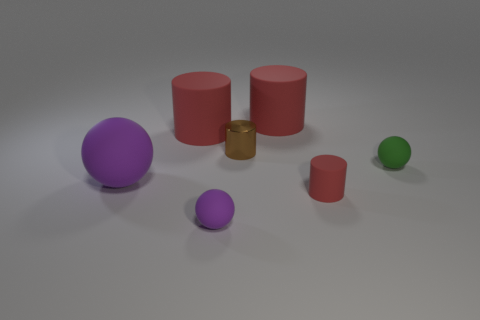Is there any other thing that is the same color as the metal object?
Make the answer very short. No. There is another tiny thing that is the same shape as the small purple rubber thing; what is its color?
Offer a very short reply. Green. Is the number of big rubber cylinders that are left of the small brown cylinder greater than the number of big red shiny balls?
Your response must be concise. Yes. There is a small cylinder that is in front of the small green matte sphere; what is its color?
Your answer should be very brief. Red. Does the metal object have the same size as the green thing?
Ensure brevity in your answer.  Yes. The green rubber object is what size?
Provide a succinct answer. Small. What is the shape of the tiny rubber thing that is the same color as the large ball?
Your answer should be compact. Sphere. Are there more small yellow blocks than tiny shiny cylinders?
Give a very brief answer. No. What is the color of the small sphere that is in front of the large thing that is left of the cylinder left of the small purple matte ball?
Keep it short and to the point. Purple. Does the red rubber object that is in front of the big purple rubber object have the same shape as the tiny brown object?
Offer a terse response. Yes. 